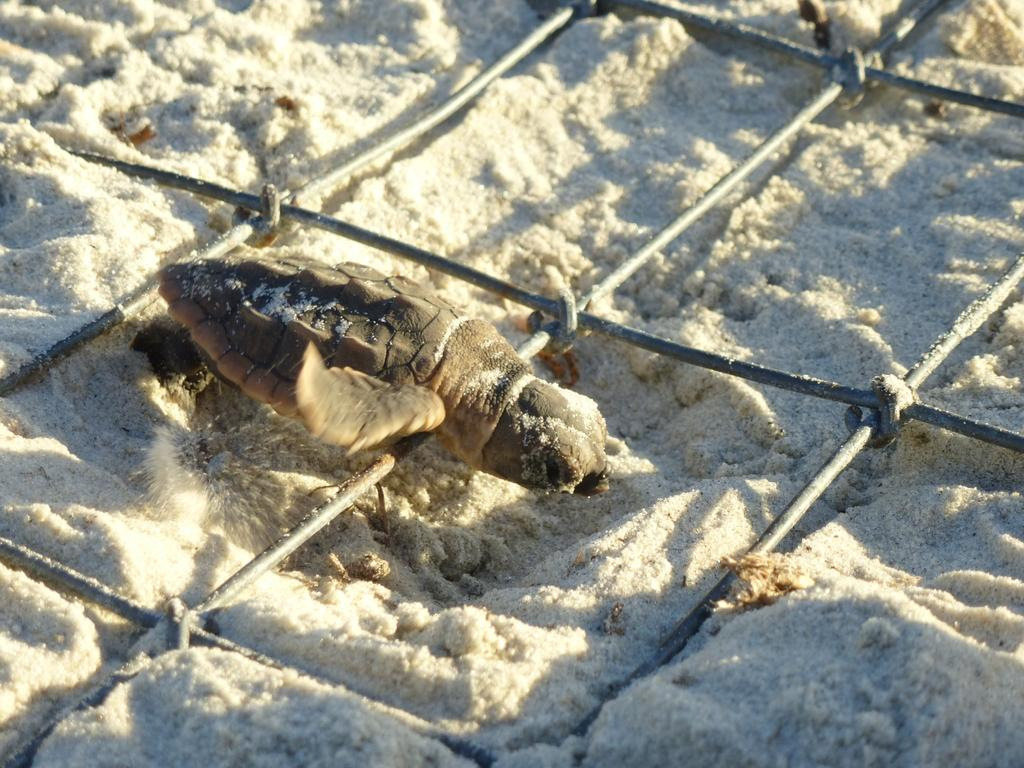What is the main subject in the foreground of the image? There is a turtle in the foreground of the image. What is the turtle resting on? The turtle is on a mesh. What type of surface is the mesh placed on? The mesh is on white sand. What type of amusement can be heard in the background of the image? There is no indication of any amusement or sound in the image; it only features a turtle on a mesh on white sand. Can you see any spots on the turtle in the image? The image does not provide enough detail to determine if there are any spots on the turtle. 